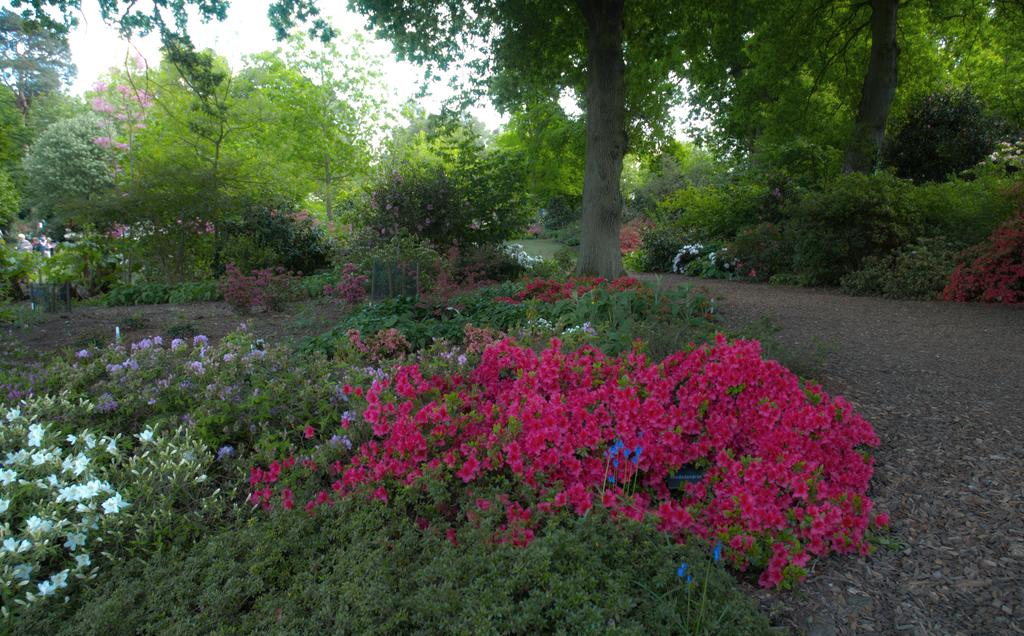What type of plants can be seen in the image? There are plants with flowers in the image. What can be seen in the background of the image? There are trees and the sky visible in the background of the image. How many times has the dime been folded in the image? There is no dime present in the image, so it cannot be folded or counted. 